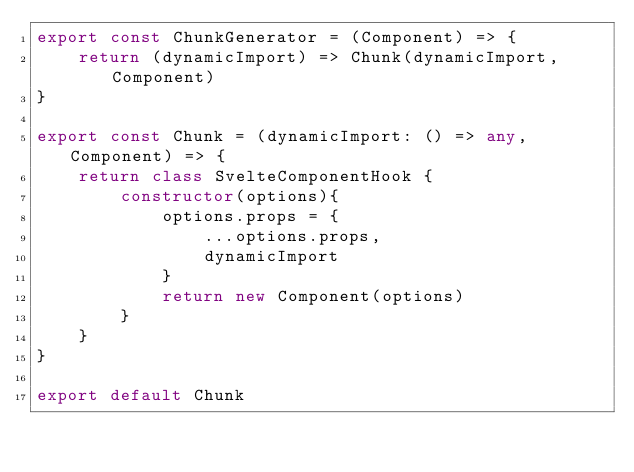Convert code to text. <code><loc_0><loc_0><loc_500><loc_500><_TypeScript_>export const ChunkGenerator = (Component) => {
    return (dynamicImport) => Chunk(dynamicImport, Component)
}

export const Chunk = (dynamicImport: () => any, Component) => {
    return class SvelteComponentHook {
        constructor(options){
            options.props = {
                ...options.props,
                dynamicImport
            }
            return new Component(options)
        }
    }
}

export default Chunk
</code> 